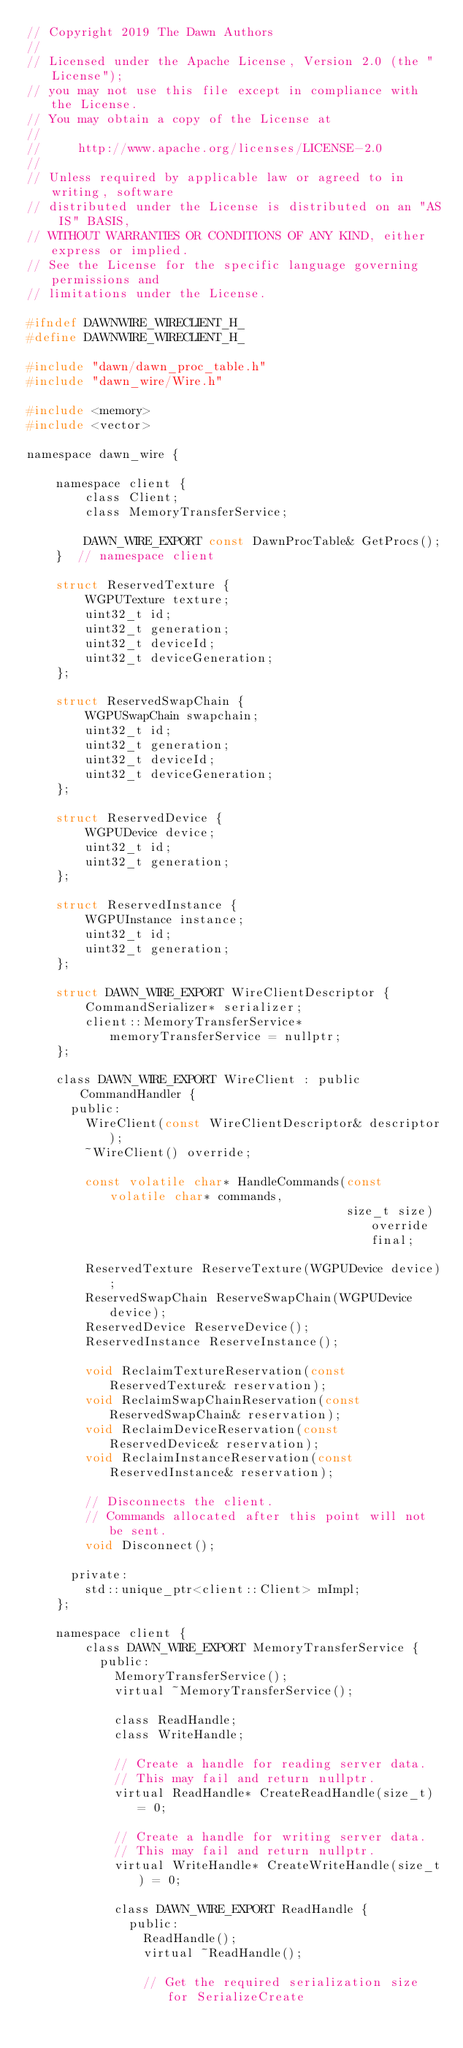<code> <loc_0><loc_0><loc_500><loc_500><_C_>// Copyright 2019 The Dawn Authors
//
// Licensed under the Apache License, Version 2.0 (the "License");
// you may not use this file except in compliance with the License.
// You may obtain a copy of the License at
//
//     http://www.apache.org/licenses/LICENSE-2.0
//
// Unless required by applicable law or agreed to in writing, software
// distributed under the License is distributed on an "AS IS" BASIS,
// WITHOUT WARRANTIES OR CONDITIONS OF ANY KIND, either express or implied.
// See the License for the specific language governing permissions and
// limitations under the License.

#ifndef DAWNWIRE_WIRECLIENT_H_
#define DAWNWIRE_WIRECLIENT_H_

#include "dawn/dawn_proc_table.h"
#include "dawn_wire/Wire.h"

#include <memory>
#include <vector>

namespace dawn_wire {

    namespace client {
        class Client;
        class MemoryTransferService;

        DAWN_WIRE_EXPORT const DawnProcTable& GetProcs();
    }  // namespace client

    struct ReservedTexture {
        WGPUTexture texture;
        uint32_t id;
        uint32_t generation;
        uint32_t deviceId;
        uint32_t deviceGeneration;
    };

    struct ReservedSwapChain {
        WGPUSwapChain swapchain;
        uint32_t id;
        uint32_t generation;
        uint32_t deviceId;
        uint32_t deviceGeneration;
    };

    struct ReservedDevice {
        WGPUDevice device;
        uint32_t id;
        uint32_t generation;
    };

    struct ReservedInstance {
        WGPUInstance instance;
        uint32_t id;
        uint32_t generation;
    };

    struct DAWN_WIRE_EXPORT WireClientDescriptor {
        CommandSerializer* serializer;
        client::MemoryTransferService* memoryTransferService = nullptr;
    };

    class DAWN_WIRE_EXPORT WireClient : public CommandHandler {
      public:
        WireClient(const WireClientDescriptor& descriptor);
        ~WireClient() override;

        const volatile char* HandleCommands(const volatile char* commands,
                                            size_t size) override final;

        ReservedTexture ReserveTexture(WGPUDevice device);
        ReservedSwapChain ReserveSwapChain(WGPUDevice device);
        ReservedDevice ReserveDevice();
        ReservedInstance ReserveInstance();

        void ReclaimTextureReservation(const ReservedTexture& reservation);
        void ReclaimSwapChainReservation(const ReservedSwapChain& reservation);
        void ReclaimDeviceReservation(const ReservedDevice& reservation);
        void ReclaimInstanceReservation(const ReservedInstance& reservation);

        // Disconnects the client.
        // Commands allocated after this point will not be sent.
        void Disconnect();

      private:
        std::unique_ptr<client::Client> mImpl;
    };

    namespace client {
        class DAWN_WIRE_EXPORT MemoryTransferService {
          public:
            MemoryTransferService();
            virtual ~MemoryTransferService();

            class ReadHandle;
            class WriteHandle;

            // Create a handle for reading server data.
            // This may fail and return nullptr.
            virtual ReadHandle* CreateReadHandle(size_t) = 0;

            // Create a handle for writing server data.
            // This may fail and return nullptr.
            virtual WriteHandle* CreateWriteHandle(size_t) = 0;

            class DAWN_WIRE_EXPORT ReadHandle {
              public:
                ReadHandle();
                virtual ~ReadHandle();

                // Get the required serialization size for SerializeCreate</code> 